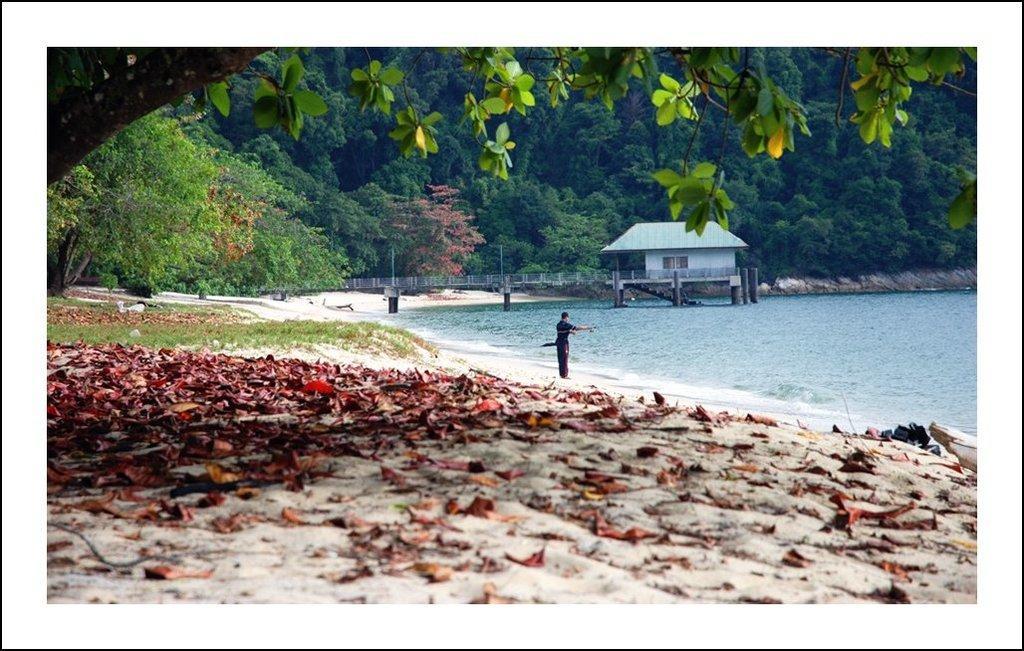Please provide a concise description of this image. This picture might be taken to the seashore. In this image, in the middle, we can see a man standing on the sand. On the right side, we can see a house, bridge, trees. On the left side, we can also see some trees, plants. At the bottom, we can see a sand with some leaves and water in an ocean. 